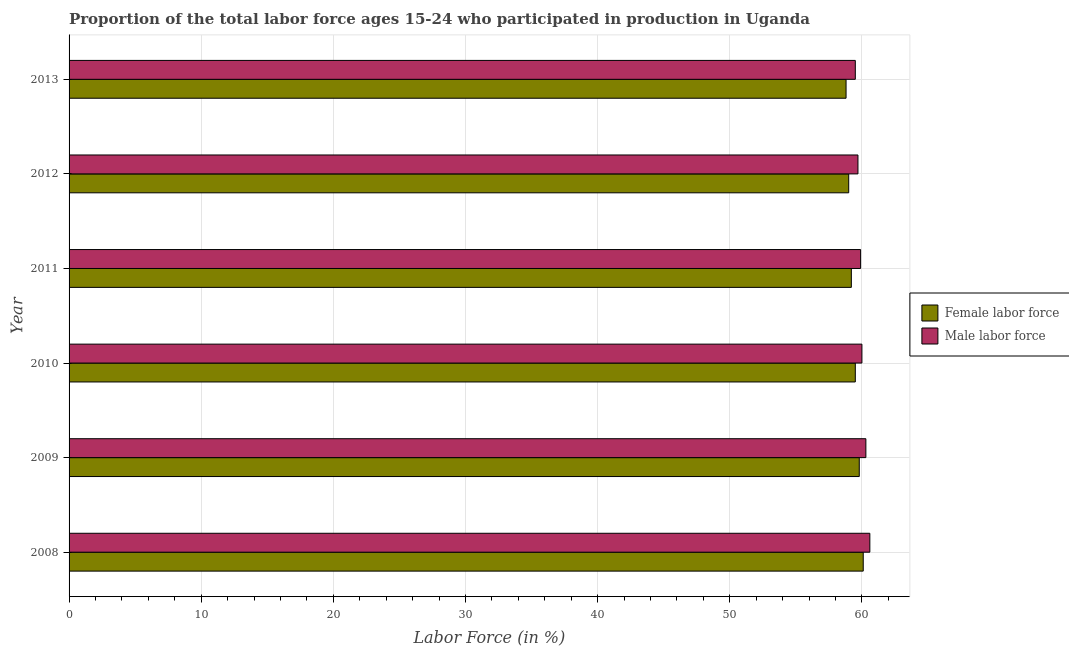How many groups of bars are there?
Ensure brevity in your answer.  6. Are the number of bars per tick equal to the number of legend labels?
Provide a succinct answer. Yes. Are the number of bars on each tick of the Y-axis equal?
Provide a short and direct response. Yes. How many bars are there on the 5th tick from the top?
Provide a short and direct response. 2. What is the percentage of male labour force in 2012?
Your response must be concise. 59.7. Across all years, what is the maximum percentage of male labour force?
Make the answer very short. 60.6. Across all years, what is the minimum percentage of female labor force?
Keep it short and to the point. 58.8. In which year was the percentage of male labour force maximum?
Offer a terse response. 2008. In which year was the percentage of male labour force minimum?
Provide a succinct answer. 2013. What is the total percentage of male labour force in the graph?
Ensure brevity in your answer.  360. What is the difference between the percentage of female labor force in 2012 and that in 2013?
Ensure brevity in your answer.  0.2. What is the difference between the percentage of male labour force in 2008 and the percentage of female labor force in 2013?
Keep it short and to the point. 1.8. What is the ratio of the percentage of female labor force in 2010 to that in 2011?
Your answer should be compact. 1. Is the percentage of male labour force in 2009 less than that in 2013?
Ensure brevity in your answer.  No. What is the difference between the highest and the lowest percentage of female labor force?
Make the answer very short. 1.3. What does the 2nd bar from the top in 2008 represents?
Give a very brief answer. Female labor force. What does the 2nd bar from the bottom in 2013 represents?
Your response must be concise. Male labor force. How many bars are there?
Keep it short and to the point. 12. Are all the bars in the graph horizontal?
Provide a succinct answer. Yes. How many years are there in the graph?
Your answer should be very brief. 6. What is the difference between two consecutive major ticks on the X-axis?
Your answer should be very brief. 10. Are the values on the major ticks of X-axis written in scientific E-notation?
Keep it short and to the point. No. Does the graph contain any zero values?
Your response must be concise. No. Where does the legend appear in the graph?
Offer a very short reply. Center right. What is the title of the graph?
Make the answer very short. Proportion of the total labor force ages 15-24 who participated in production in Uganda. What is the label or title of the Y-axis?
Make the answer very short. Year. What is the Labor Force (in %) of Female labor force in 2008?
Offer a terse response. 60.1. What is the Labor Force (in %) of Male labor force in 2008?
Your answer should be very brief. 60.6. What is the Labor Force (in %) of Female labor force in 2009?
Provide a succinct answer. 59.8. What is the Labor Force (in %) in Male labor force in 2009?
Offer a terse response. 60.3. What is the Labor Force (in %) in Female labor force in 2010?
Provide a short and direct response. 59.5. What is the Labor Force (in %) of Female labor force in 2011?
Your answer should be very brief. 59.2. What is the Labor Force (in %) of Male labor force in 2011?
Ensure brevity in your answer.  59.9. What is the Labor Force (in %) of Male labor force in 2012?
Your response must be concise. 59.7. What is the Labor Force (in %) of Female labor force in 2013?
Offer a very short reply. 58.8. What is the Labor Force (in %) in Male labor force in 2013?
Your answer should be compact. 59.5. Across all years, what is the maximum Labor Force (in %) of Female labor force?
Your answer should be very brief. 60.1. Across all years, what is the maximum Labor Force (in %) in Male labor force?
Your response must be concise. 60.6. Across all years, what is the minimum Labor Force (in %) of Female labor force?
Your answer should be compact. 58.8. Across all years, what is the minimum Labor Force (in %) in Male labor force?
Offer a terse response. 59.5. What is the total Labor Force (in %) of Female labor force in the graph?
Your response must be concise. 356.4. What is the total Labor Force (in %) of Male labor force in the graph?
Provide a succinct answer. 360. What is the difference between the Labor Force (in %) of Female labor force in 2008 and that in 2009?
Offer a very short reply. 0.3. What is the difference between the Labor Force (in %) in Female labor force in 2008 and that in 2010?
Give a very brief answer. 0.6. What is the difference between the Labor Force (in %) in Male labor force in 2008 and that in 2011?
Provide a short and direct response. 0.7. What is the difference between the Labor Force (in %) of Female labor force in 2008 and that in 2012?
Keep it short and to the point. 1.1. What is the difference between the Labor Force (in %) of Male labor force in 2008 and that in 2012?
Make the answer very short. 0.9. What is the difference between the Labor Force (in %) in Male labor force in 2008 and that in 2013?
Offer a terse response. 1.1. What is the difference between the Labor Force (in %) of Female labor force in 2009 and that in 2010?
Keep it short and to the point. 0.3. What is the difference between the Labor Force (in %) in Female labor force in 2009 and that in 2011?
Provide a succinct answer. 0.6. What is the difference between the Labor Force (in %) of Female labor force in 2009 and that in 2012?
Ensure brevity in your answer.  0.8. What is the difference between the Labor Force (in %) in Male labor force in 2009 and that in 2013?
Your answer should be very brief. 0.8. What is the difference between the Labor Force (in %) of Female labor force in 2010 and that in 2011?
Offer a terse response. 0.3. What is the difference between the Labor Force (in %) of Male labor force in 2010 and that in 2011?
Provide a short and direct response. 0.1. What is the difference between the Labor Force (in %) of Male labor force in 2010 and that in 2012?
Your answer should be compact. 0.3. What is the difference between the Labor Force (in %) of Male labor force in 2010 and that in 2013?
Offer a very short reply. 0.5. What is the difference between the Labor Force (in %) of Female labor force in 2011 and that in 2012?
Make the answer very short. 0.2. What is the difference between the Labor Force (in %) in Female labor force in 2008 and the Labor Force (in %) in Male labor force in 2011?
Give a very brief answer. 0.2. What is the difference between the Labor Force (in %) in Female labor force in 2008 and the Labor Force (in %) in Male labor force in 2013?
Your answer should be compact. 0.6. What is the difference between the Labor Force (in %) in Female labor force in 2009 and the Labor Force (in %) in Male labor force in 2010?
Your response must be concise. -0.2. What is the difference between the Labor Force (in %) in Female labor force in 2009 and the Labor Force (in %) in Male labor force in 2013?
Your answer should be compact. 0.3. What is the difference between the Labor Force (in %) in Female labor force in 2010 and the Labor Force (in %) in Male labor force in 2011?
Keep it short and to the point. -0.4. What is the difference between the Labor Force (in %) in Female labor force in 2010 and the Labor Force (in %) in Male labor force in 2012?
Give a very brief answer. -0.2. What is the difference between the Labor Force (in %) of Female labor force in 2010 and the Labor Force (in %) of Male labor force in 2013?
Your answer should be very brief. 0. What is the difference between the Labor Force (in %) in Female labor force in 2011 and the Labor Force (in %) in Male labor force in 2012?
Your answer should be compact. -0.5. What is the difference between the Labor Force (in %) in Female labor force in 2011 and the Labor Force (in %) in Male labor force in 2013?
Provide a succinct answer. -0.3. What is the difference between the Labor Force (in %) in Female labor force in 2012 and the Labor Force (in %) in Male labor force in 2013?
Ensure brevity in your answer.  -0.5. What is the average Labor Force (in %) in Female labor force per year?
Your response must be concise. 59.4. What is the average Labor Force (in %) of Male labor force per year?
Offer a very short reply. 60. In the year 2009, what is the difference between the Labor Force (in %) of Female labor force and Labor Force (in %) of Male labor force?
Offer a very short reply. -0.5. In the year 2011, what is the difference between the Labor Force (in %) in Female labor force and Labor Force (in %) in Male labor force?
Make the answer very short. -0.7. In the year 2012, what is the difference between the Labor Force (in %) of Female labor force and Labor Force (in %) of Male labor force?
Offer a terse response. -0.7. In the year 2013, what is the difference between the Labor Force (in %) in Female labor force and Labor Force (in %) in Male labor force?
Offer a terse response. -0.7. What is the ratio of the Labor Force (in %) in Female labor force in 2008 to that in 2009?
Offer a very short reply. 1. What is the ratio of the Labor Force (in %) in Male labor force in 2008 to that in 2009?
Ensure brevity in your answer.  1. What is the ratio of the Labor Force (in %) of Female labor force in 2008 to that in 2011?
Provide a succinct answer. 1.02. What is the ratio of the Labor Force (in %) of Male labor force in 2008 to that in 2011?
Your response must be concise. 1.01. What is the ratio of the Labor Force (in %) of Female labor force in 2008 to that in 2012?
Your response must be concise. 1.02. What is the ratio of the Labor Force (in %) of Male labor force in 2008 to that in 2012?
Give a very brief answer. 1.02. What is the ratio of the Labor Force (in %) of Female labor force in 2008 to that in 2013?
Your answer should be very brief. 1.02. What is the ratio of the Labor Force (in %) in Male labor force in 2008 to that in 2013?
Provide a short and direct response. 1.02. What is the ratio of the Labor Force (in %) in Male labor force in 2009 to that in 2010?
Ensure brevity in your answer.  1. What is the ratio of the Labor Force (in %) of Female labor force in 2009 to that in 2012?
Offer a very short reply. 1.01. What is the ratio of the Labor Force (in %) of Male labor force in 2009 to that in 2013?
Offer a terse response. 1.01. What is the ratio of the Labor Force (in %) in Male labor force in 2010 to that in 2011?
Offer a terse response. 1. What is the ratio of the Labor Force (in %) in Female labor force in 2010 to that in 2012?
Your answer should be compact. 1.01. What is the ratio of the Labor Force (in %) in Male labor force in 2010 to that in 2012?
Your answer should be very brief. 1. What is the ratio of the Labor Force (in %) of Female labor force in 2010 to that in 2013?
Provide a short and direct response. 1.01. What is the ratio of the Labor Force (in %) in Male labor force in 2010 to that in 2013?
Offer a terse response. 1.01. What is the ratio of the Labor Force (in %) in Female labor force in 2011 to that in 2012?
Your response must be concise. 1. What is the ratio of the Labor Force (in %) in Female labor force in 2011 to that in 2013?
Ensure brevity in your answer.  1.01. What is the ratio of the Labor Force (in %) of Male labor force in 2012 to that in 2013?
Your response must be concise. 1. What is the difference between the highest and the lowest Labor Force (in %) in Female labor force?
Your response must be concise. 1.3. 